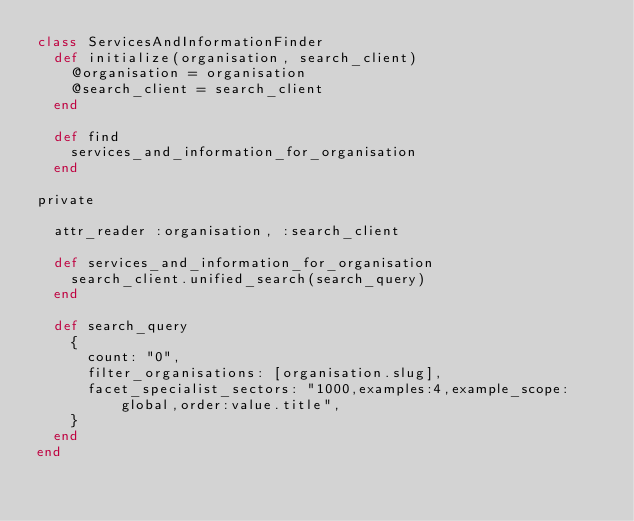<code> <loc_0><loc_0><loc_500><loc_500><_Ruby_>class ServicesAndInformationFinder
  def initialize(organisation, search_client)
    @organisation = organisation
    @search_client = search_client
  end

  def find
    services_and_information_for_organisation
  end

private

  attr_reader :organisation, :search_client

  def services_and_information_for_organisation
    search_client.unified_search(search_query)
  end

  def search_query
    {
      count: "0",
      filter_organisations: [organisation.slug],
      facet_specialist_sectors: "1000,examples:4,example_scope:global,order:value.title",
    }
  end
end
</code> 